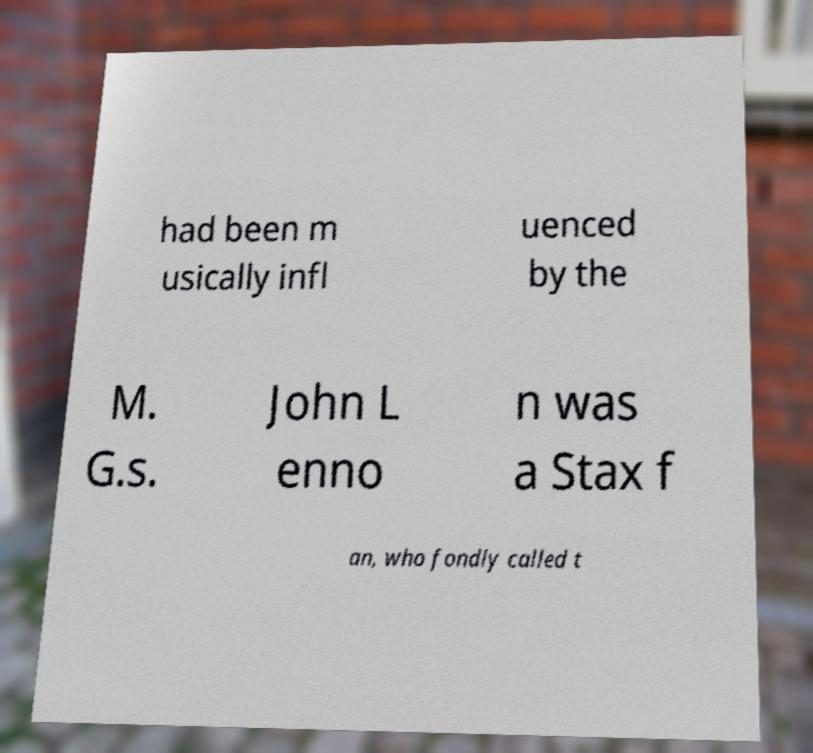What messages or text are displayed in this image? I need them in a readable, typed format. had been m usically infl uenced by the M. G.s. John L enno n was a Stax f an, who fondly called t 